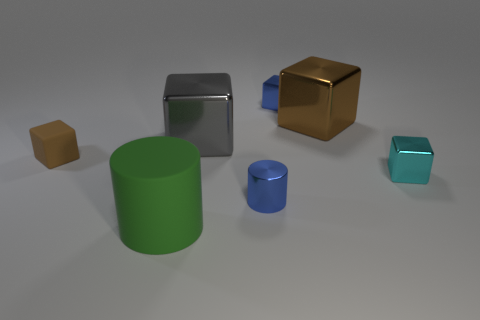How would you describe the lighting environment where these objects are placed? The lighting environment appears to be diffused and soft, with no harsh shadows visible, suggesting an indoor setting with well-distributed light, likely coming from multiple sources that help reduce contrast and soften shadows. 